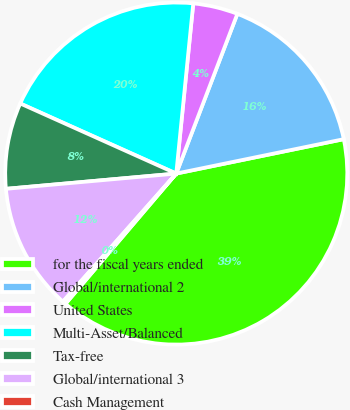<chart> <loc_0><loc_0><loc_500><loc_500><pie_chart><fcel>for the fiscal years ended<fcel>Global/international 2<fcel>United States<fcel>Multi-Asset/Balanced<fcel>Tax-free<fcel>Global/international 3<fcel>Cash Management<nl><fcel>39.44%<fcel>15.96%<fcel>4.23%<fcel>19.87%<fcel>8.14%<fcel>12.05%<fcel>0.31%<nl></chart> 